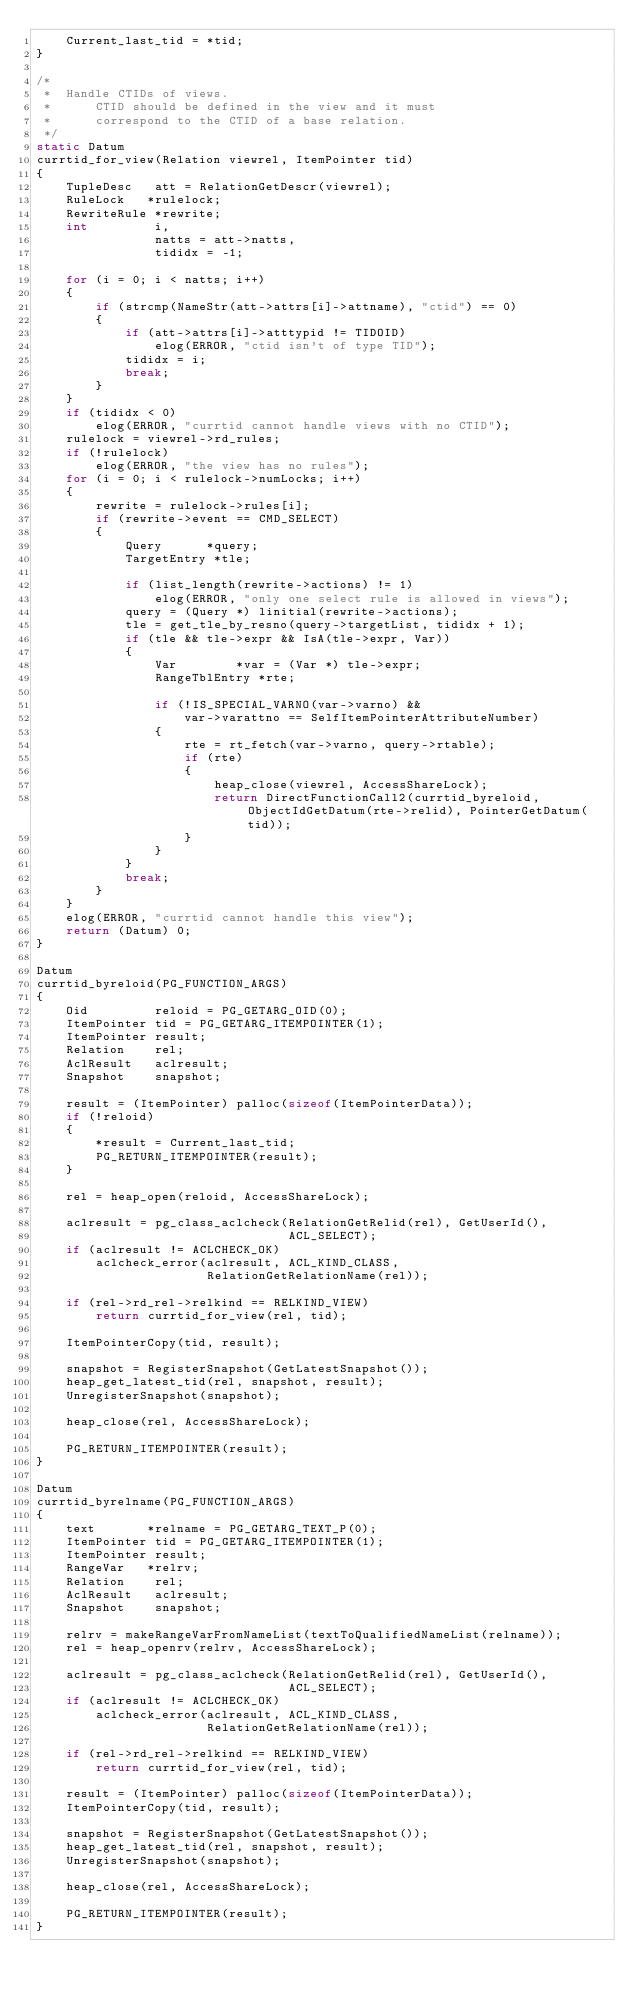Convert code to text. <code><loc_0><loc_0><loc_500><loc_500><_C_>	Current_last_tid = *tid;
}

/*
 *	Handle CTIDs of views.
 *		CTID should be defined in the view and it must
 *		correspond to the CTID of a base relation.
 */
static Datum
currtid_for_view(Relation viewrel, ItemPointer tid)
{
	TupleDesc	att = RelationGetDescr(viewrel);
	RuleLock   *rulelock;
	RewriteRule *rewrite;
	int			i,
				natts = att->natts,
				tididx = -1;

	for (i = 0; i < natts; i++)
	{
		if (strcmp(NameStr(att->attrs[i]->attname), "ctid") == 0)
		{
			if (att->attrs[i]->atttypid != TIDOID)
				elog(ERROR, "ctid isn't of type TID");
			tididx = i;
			break;
		}
	}
	if (tididx < 0)
		elog(ERROR, "currtid cannot handle views with no CTID");
	rulelock = viewrel->rd_rules;
	if (!rulelock)
		elog(ERROR, "the view has no rules");
	for (i = 0; i < rulelock->numLocks; i++)
	{
		rewrite = rulelock->rules[i];
		if (rewrite->event == CMD_SELECT)
		{
			Query	   *query;
			TargetEntry *tle;

			if (list_length(rewrite->actions) != 1)
				elog(ERROR, "only one select rule is allowed in views");
			query = (Query *) linitial(rewrite->actions);
			tle = get_tle_by_resno(query->targetList, tididx + 1);
			if (tle && tle->expr && IsA(tle->expr, Var))
			{
				Var		   *var = (Var *) tle->expr;
				RangeTblEntry *rte;

				if (!IS_SPECIAL_VARNO(var->varno) &&
					var->varattno == SelfItemPointerAttributeNumber)
				{
					rte = rt_fetch(var->varno, query->rtable);
					if (rte)
					{
						heap_close(viewrel, AccessShareLock);
						return DirectFunctionCall2(currtid_byreloid, ObjectIdGetDatum(rte->relid), PointerGetDatum(tid));
					}
				}
			}
			break;
		}
	}
	elog(ERROR, "currtid cannot handle this view");
	return (Datum) 0;
}

Datum
currtid_byreloid(PG_FUNCTION_ARGS)
{
	Oid			reloid = PG_GETARG_OID(0);
	ItemPointer tid = PG_GETARG_ITEMPOINTER(1);
	ItemPointer result;
	Relation	rel;
	AclResult	aclresult;
	Snapshot	snapshot;

	result = (ItemPointer) palloc(sizeof(ItemPointerData));
	if (!reloid)
	{
		*result = Current_last_tid;
		PG_RETURN_ITEMPOINTER(result);
	}

	rel = heap_open(reloid, AccessShareLock);

	aclresult = pg_class_aclcheck(RelationGetRelid(rel), GetUserId(),
								  ACL_SELECT);
	if (aclresult != ACLCHECK_OK)
		aclcheck_error(aclresult, ACL_KIND_CLASS,
					   RelationGetRelationName(rel));

	if (rel->rd_rel->relkind == RELKIND_VIEW)
		return currtid_for_view(rel, tid);

	ItemPointerCopy(tid, result);

	snapshot = RegisterSnapshot(GetLatestSnapshot());
	heap_get_latest_tid(rel, snapshot, result);
	UnregisterSnapshot(snapshot);

	heap_close(rel, AccessShareLock);

	PG_RETURN_ITEMPOINTER(result);
}

Datum
currtid_byrelname(PG_FUNCTION_ARGS)
{
	text	   *relname = PG_GETARG_TEXT_P(0);
	ItemPointer tid = PG_GETARG_ITEMPOINTER(1);
	ItemPointer result;
	RangeVar   *relrv;
	Relation	rel;
	AclResult	aclresult;
	Snapshot	snapshot;

	relrv = makeRangeVarFromNameList(textToQualifiedNameList(relname));
	rel = heap_openrv(relrv, AccessShareLock);

	aclresult = pg_class_aclcheck(RelationGetRelid(rel), GetUserId(),
								  ACL_SELECT);
	if (aclresult != ACLCHECK_OK)
		aclcheck_error(aclresult, ACL_KIND_CLASS,
					   RelationGetRelationName(rel));

	if (rel->rd_rel->relkind == RELKIND_VIEW)
		return currtid_for_view(rel, tid);

	result = (ItemPointer) palloc(sizeof(ItemPointerData));
	ItemPointerCopy(tid, result);

	snapshot = RegisterSnapshot(GetLatestSnapshot());
	heap_get_latest_tid(rel, snapshot, result);
	UnregisterSnapshot(snapshot);

	heap_close(rel, AccessShareLock);

	PG_RETURN_ITEMPOINTER(result);
}
</code> 